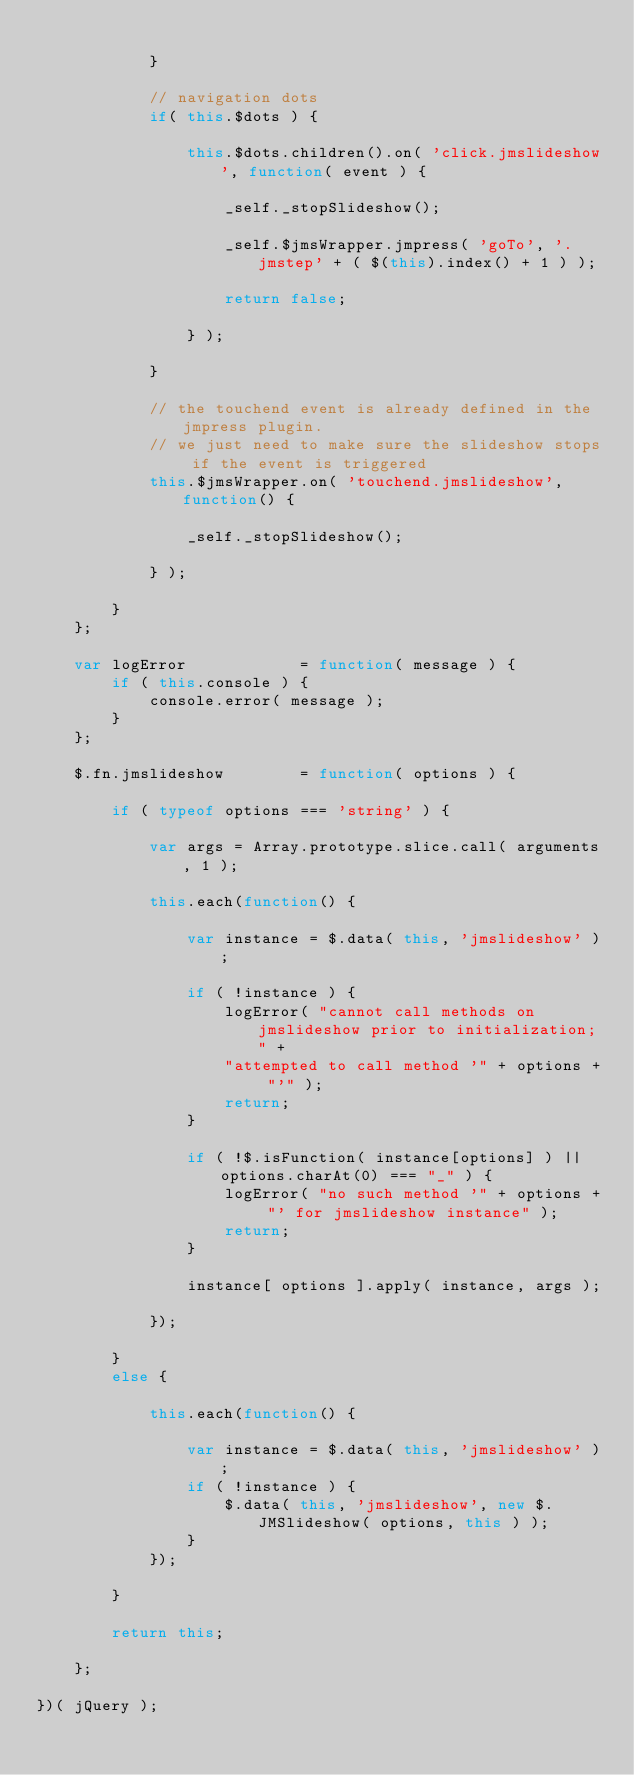<code> <loc_0><loc_0><loc_500><loc_500><_JavaScript_>				
			}
			
			// navigation dots
			if( this.$dots ) {
			
				this.$dots.children().on( 'click.jmslideshow', function( event ) {
				 	
					_self._stopSlideshow();
					
					_self.$jmsWrapper.jmpress( 'goTo', '.jmstep' + ( $(this).index() + 1 ) );
					
					return false;
				
				} );
			
			}
			
			// the touchend event is already defined in the jmpress plugin.
			// we just need to make sure the slideshow stops if the event is triggered
			this.$jmsWrapper.on( 'touchend.jmslideshow', function() {
			
				_self._stopSlideshow();
			
			} );
			
		}
	};
	
	var logError 			= function( message ) {
		if ( this.console ) {
			console.error( message );
		}
	};
	
	$.fn.jmslideshow		= function( options ) {
	
		if ( typeof options === 'string' ) {
			
			var args = Array.prototype.slice.call( arguments, 1 );
			
			this.each(function() {
			
				var instance = $.data( this, 'jmslideshow' );
				
				if ( !instance ) {
					logError( "cannot call methods on jmslideshow prior to initialization; " +
					"attempted to call method '" + options + "'" );
					return;
				}
				
				if ( !$.isFunction( instance[options] ) || options.charAt(0) === "_" ) {
					logError( "no such method '" + options + "' for jmslideshow instance" );
					return;
				}
				
				instance[ options ].apply( instance, args );
			
			});
		
		} 
		else {
		
			this.each(function() {
			
				var instance = $.data( this, 'jmslideshow' );
				if ( !instance ) {
					$.data( this, 'jmslideshow', new $.JMSlideshow( options, this ) );
				}
			});
		
		}
		
		return this;
		
	};
	
})( jQuery );</code> 